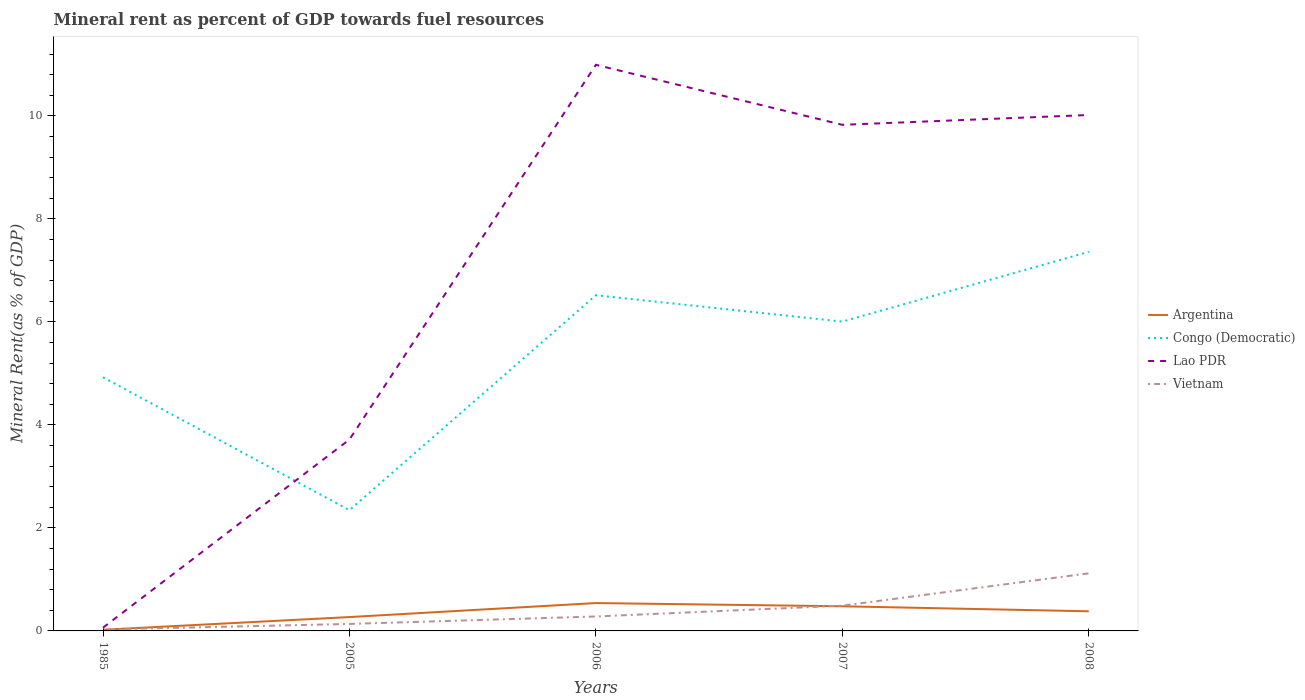Does the line corresponding to Lao PDR intersect with the line corresponding to Congo (Democratic)?
Ensure brevity in your answer.  Yes. Across all years, what is the maximum mineral rent in Congo (Democratic)?
Your answer should be compact. 2.34. In which year was the mineral rent in Congo (Democratic) maximum?
Make the answer very short. 2005. What is the total mineral rent in Vietnam in the graph?
Give a very brief answer. -0.15. What is the difference between the highest and the second highest mineral rent in Vietnam?
Offer a terse response. 1.09. How many lines are there?
Offer a very short reply. 4. What is the difference between two consecutive major ticks on the Y-axis?
Offer a terse response. 2. Are the values on the major ticks of Y-axis written in scientific E-notation?
Your response must be concise. No. Does the graph contain any zero values?
Offer a terse response. No. Where does the legend appear in the graph?
Make the answer very short. Center right. What is the title of the graph?
Give a very brief answer. Mineral rent as percent of GDP towards fuel resources. Does "Morocco" appear as one of the legend labels in the graph?
Your answer should be compact. No. What is the label or title of the X-axis?
Make the answer very short. Years. What is the label or title of the Y-axis?
Your answer should be compact. Mineral Rent(as % of GDP). What is the Mineral Rent(as % of GDP) of Argentina in 1985?
Keep it short and to the point. 0.02. What is the Mineral Rent(as % of GDP) of Congo (Democratic) in 1985?
Provide a succinct answer. 4.92. What is the Mineral Rent(as % of GDP) of Lao PDR in 1985?
Your answer should be very brief. 0.06. What is the Mineral Rent(as % of GDP) of Vietnam in 1985?
Your answer should be compact. 0.03. What is the Mineral Rent(as % of GDP) in Argentina in 2005?
Offer a terse response. 0.27. What is the Mineral Rent(as % of GDP) in Congo (Democratic) in 2005?
Provide a short and direct response. 2.34. What is the Mineral Rent(as % of GDP) of Lao PDR in 2005?
Your answer should be very brief. 3.72. What is the Mineral Rent(as % of GDP) of Vietnam in 2005?
Offer a very short reply. 0.14. What is the Mineral Rent(as % of GDP) in Argentina in 2006?
Your answer should be very brief. 0.54. What is the Mineral Rent(as % of GDP) of Congo (Democratic) in 2006?
Offer a terse response. 6.52. What is the Mineral Rent(as % of GDP) of Lao PDR in 2006?
Provide a short and direct response. 10.99. What is the Mineral Rent(as % of GDP) of Vietnam in 2006?
Keep it short and to the point. 0.28. What is the Mineral Rent(as % of GDP) in Argentina in 2007?
Offer a terse response. 0.48. What is the Mineral Rent(as % of GDP) of Congo (Democratic) in 2007?
Give a very brief answer. 6.01. What is the Mineral Rent(as % of GDP) of Lao PDR in 2007?
Offer a very short reply. 9.83. What is the Mineral Rent(as % of GDP) in Vietnam in 2007?
Your response must be concise. 0.49. What is the Mineral Rent(as % of GDP) of Argentina in 2008?
Keep it short and to the point. 0.38. What is the Mineral Rent(as % of GDP) in Congo (Democratic) in 2008?
Provide a short and direct response. 7.36. What is the Mineral Rent(as % of GDP) in Lao PDR in 2008?
Ensure brevity in your answer.  10.02. What is the Mineral Rent(as % of GDP) in Vietnam in 2008?
Provide a short and direct response. 1.12. Across all years, what is the maximum Mineral Rent(as % of GDP) of Argentina?
Provide a succinct answer. 0.54. Across all years, what is the maximum Mineral Rent(as % of GDP) in Congo (Democratic)?
Provide a succinct answer. 7.36. Across all years, what is the maximum Mineral Rent(as % of GDP) in Lao PDR?
Make the answer very short. 10.99. Across all years, what is the maximum Mineral Rent(as % of GDP) in Vietnam?
Your response must be concise. 1.12. Across all years, what is the minimum Mineral Rent(as % of GDP) of Argentina?
Provide a succinct answer. 0.02. Across all years, what is the minimum Mineral Rent(as % of GDP) in Congo (Democratic)?
Your answer should be compact. 2.34. Across all years, what is the minimum Mineral Rent(as % of GDP) in Lao PDR?
Ensure brevity in your answer.  0.06. Across all years, what is the minimum Mineral Rent(as % of GDP) of Vietnam?
Give a very brief answer. 0.03. What is the total Mineral Rent(as % of GDP) of Argentina in the graph?
Ensure brevity in your answer.  1.69. What is the total Mineral Rent(as % of GDP) in Congo (Democratic) in the graph?
Offer a terse response. 27.15. What is the total Mineral Rent(as % of GDP) in Lao PDR in the graph?
Provide a short and direct response. 34.61. What is the total Mineral Rent(as % of GDP) of Vietnam in the graph?
Give a very brief answer. 2.05. What is the difference between the Mineral Rent(as % of GDP) in Argentina in 1985 and that in 2005?
Provide a short and direct response. -0.25. What is the difference between the Mineral Rent(as % of GDP) in Congo (Democratic) in 1985 and that in 2005?
Offer a very short reply. 2.58. What is the difference between the Mineral Rent(as % of GDP) in Lao PDR in 1985 and that in 2005?
Your answer should be very brief. -3.65. What is the difference between the Mineral Rent(as % of GDP) of Vietnam in 1985 and that in 2005?
Your answer should be very brief. -0.11. What is the difference between the Mineral Rent(as % of GDP) in Argentina in 1985 and that in 2006?
Make the answer very short. -0.52. What is the difference between the Mineral Rent(as % of GDP) in Congo (Democratic) in 1985 and that in 2006?
Ensure brevity in your answer.  -1.59. What is the difference between the Mineral Rent(as % of GDP) in Lao PDR in 1985 and that in 2006?
Provide a short and direct response. -10.93. What is the difference between the Mineral Rent(as % of GDP) of Vietnam in 1985 and that in 2006?
Keep it short and to the point. -0.25. What is the difference between the Mineral Rent(as % of GDP) of Argentina in 1985 and that in 2007?
Keep it short and to the point. -0.46. What is the difference between the Mineral Rent(as % of GDP) in Congo (Democratic) in 1985 and that in 2007?
Offer a terse response. -1.08. What is the difference between the Mineral Rent(as % of GDP) of Lao PDR in 1985 and that in 2007?
Provide a short and direct response. -9.76. What is the difference between the Mineral Rent(as % of GDP) of Vietnam in 1985 and that in 2007?
Provide a short and direct response. -0.46. What is the difference between the Mineral Rent(as % of GDP) of Argentina in 1985 and that in 2008?
Provide a succinct answer. -0.36. What is the difference between the Mineral Rent(as % of GDP) of Congo (Democratic) in 1985 and that in 2008?
Provide a succinct answer. -2.43. What is the difference between the Mineral Rent(as % of GDP) of Lao PDR in 1985 and that in 2008?
Offer a very short reply. -9.95. What is the difference between the Mineral Rent(as % of GDP) of Vietnam in 1985 and that in 2008?
Ensure brevity in your answer.  -1.09. What is the difference between the Mineral Rent(as % of GDP) of Argentina in 2005 and that in 2006?
Offer a very short reply. -0.27. What is the difference between the Mineral Rent(as % of GDP) of Congo (Democratic) in 2005 and that in 2006?
Provide a short and direct response. -4.17. What is the difference between the Mineral Rent(as % of GDP) in Lao PDR in 2005 and that in 2006?
Ensure brevity in your answer.  -7.27. What is the difference between the Mineral Rent(as % of GDP) in Vietnam in 2005 and that in 2006?
Your answer should be compact. -0.14. What is the difference between the Mineral Rent(as % of GDP) in Argentina in 2005 and that in 2007?
Your response must be concise. -0.21. What is the difference between the Mineral Rent(as % of GDP) of Congo (Democratic) in 2005 and that in 2007?
Provide a succinct answer. -3.66. What is the difference between the Mineral Rent(as % of GDP) in Lao PDR in 2005 and that in 2007?
Ensure brevity in your answer.  -6.11. What is the difference between the Mineral Rent(as % of GDP) of Vietnam in 2005 and that in 2007?
Ensure brevity in your answer.  -0.35. What is the difference between the Mineral Rent(as % of GDP) in Argentina in 2005 and that in 2008?
Offer a terse response. -0.11. What is the difference between the Mineral Rent(as % of GDP) of Congo (Democratic) in 2005 and that in 2008?
Provide a succinct answer. -5.01. What is the difference between the Mineral Rent(as % of GDP) in Lao PDR in 2005 and that in 2008?
Keep it short and to the point. -6.3. What is the difference between the Mineral Rent(as % of GDP) in Vietnam in 2005 and that in 2008?
Offer a very short reply. -0.98. What is the difference between the Mineral Rent(as % of GDP) in Argentina in 2006 and that in 2007?
Your answer should be very brief. 0.06. What is the difference between the Mineral Rent(as % of GDP) in Congo (Democratic) in 2006 and that in 2007?
Provide a short and direct response. 0.51. What is the difference between the Mineral Rent(as % of GDP) in Lao PDR in 2006 and that in 2007?
Give a very brief answer. 1.16. What is the difference between the Mineral Rent(as % of GDP) in Vietnam in 2006 and that in 2007?
Give a very brief answer. -0.21. What is the difference between the Mineral Rent(as % of GDP) of Argentina in 2006 and that in 2008?
Ensure brevity in your answer.  0.16. What is the difference between the Mineral Rent(as % of GDP) in Congo (Democratic) in 2006 and that in 2008?
Keep it short and to the point. -0.84. What is the difference between the Mineral Rent(as % of GDP) in Lao PDR in 2006 and that in 2008?
Provide a short and direct response. 0.97. What is the difference between the Mineral Rent(as % of GDP) of Vietnam in 2006 and that in 2008?
Give a very brief answer. -0.84. What is the difference between the Mineral Rent(as % of GDP) of Argentina in 2007 and that in 2008?
Offer a very short reply. 0.1. What is the difference between the Mineral Rent(as % of GDP) of Congo (Democratic) in 2007 and that in 2008?
Provide a succinct answer. -1.35. What is the difference between the Mineral Rent(as % of GDP) of Lao PDR in 2007 and that in 2008?
Offer a terse response. -0.19. What is the difference between the Mineral Rent(as % of GDP) of Vietnam in 2007 and that in 2008?
Your answer should be very brief. -0.63. What is the difference between the Mineral Rent(as % of GDP) in Argentina in 1985 and the Mineral Rent(as % of GDP) in Congo (Democratic) in 2005?
Provide a succinct answer. -2.32. What is the difference between the Mineral Rent(as % of GDP) of Argentina in 1985 and the Mineral Rent(as % of GDP) of Lao PDR in 2005?
Provide a succinct answer. -3.69. What is the difference between the Mineral Rent(as % of GDP) of Argentina in 1985 and the Mineral Rent(as % of GDP) of Vietnam in 2005?
Offer a very short reply. -0.11. What is the difference between the Mineral Rent(as % of GDP) of Congo (Democratic) in 1985 and the Mineral Rent(as % of GDP) of Lao PDR in 2005?
Ensure brevity in your answer.  1.21. What is the difference between the Mineral Rent(as % of GDP) of Congo (Democratic) in 1985 and the Mineral Rent(as % of GDP) of Vietnam in 2005?
Give a very brief answer. 4.79. What is the difference between the Mineral Rent(as % of GDP) of Lao PDR in 1985 and the Mineral Rent(as % of GDP) of Vietnam in 2005?
Your response must be concise. -0.07. What is the difference between the Mineral Rent(as % of GDP) of Argentina in 1985 and the Mineral Rent(as % of GDP) of Congo (Democratic) in 2006?
Your answer should be very brief. -6.49. What is the difference between the Mineral Rent(as % of GDP) in Argentina in 1985 and the Mineral Rent(as % of GDP) in Lao PDR in 2006?
Your response must be concise. -10.97. What is the difference between the Mineral Rent(as % of GDP) of Argentina in 1985 and the Mineral Rent(as % of GDP) of Vietnam in 2006?
Keep it short and to the point. -0.26. What is the difference between the Mineral Rent(as % of GDP) of Congo (Democratic) in 1985 and the Mineral Rent(as % of GDP) of Lao PDR in 2006?
Offer a very short reply. -6.07. What is the difference between the Mineral Rent(as % of GDP) in Congo (Democratic) in 1985 and the Mineral Rent(as % of GDP) in Vietnam in 2006?
Your answer should be compact. 4.64. What is the difference between the Mineral Rent(as % of GDP) in Lao PDR in 1985 and the Mineral Rent(as % of GDP) in Vietnam in 2006?
Provide a succinct answer. -0.22. What is the difference between the Mineral Rent(as % of GDP) in Argentina in 1985 and the Mineral Rent(as % of GDP) in Congo (Democratic) in 2007?
Provide a succinct answer. -5.98. What is the difference between the Mineral Rent(as % of GDP) of Argentina in 1985 and the Mineral Rent(as % of GDP) of Lao PDR in 2007?
Make the answer very short. -9.8. What is the difference between the Mineral Rent(as % of GDP) in Argentina in 1985 and the Mineral Rent(as % of GDP) in Vietnam in 2007?
Give a very brief answer. -0.47. What is the difference between the Mineral Rent(as % of GDP) in Congo (Democratic) in 1985 and the Mineral Rent(as % of GDP) in Lao PDR in 2007?
Your answer should be compact. -4.9. What is the difference between the Mineral Rent(as % of GDP) in Congo (Democratic) in 1985 and the Mineral Rent(as % of GDP) in Vietnam in 2007?
Keep it short and to the point. 4.43. What is the difference between the Mineral Rent(as % of GDP) in Lao PDR in 1985 and the Mineral Rent(as % of GDP) in Vietnam in 2007?
Give a very brief answer. -0.43. What is the difference between the Mineral Rent(as % of GDP) of Argentina in 1985 and the Mineral Rent(as % of GDP) of Congo (Democratic) in 2008?
Offer a very short reply. -7.34. What is the difference between the Mineral Rent(as % of GDP) of Argentina in 1985 and the Mineral Rent(as % of GDP) of Lao PDR in 2008?
Your response must be concise. -9.99. What is the difference between the Mineral Rent(as % of GDP) in Argentina in 1985 and the Mineral Rent(as % of GDP) in Vietnam in 2008?
Provide a succinct answer. -1.1. What is the difference between the Mineral Rent(as % of GDP) of Congo (Democratic) in 1985 and the Mineral Rent(as % of GDP) of Lao PDR in 2008?
Offer a very short reply. -5.09. What is the difference between the Mineral Rent(as % of GDP) of Congo (Democratic) in 1985 and the Mineral Rent(as % of GDP) of Vietnam in 2008?
Your answer should be very brief. 3.81. What is the difference between the Mineral Rent(as % of GDP) of Lao PDR in 1985 and the Mineral Rent(as % of GDP) of Vietnam in 2008?
Keep it short and to the point. -1.05. What is the difference between the Mineral Rent(as % of GDP) of Argentina in 2005 and the Mineral Rent(as % of GDP) of Congo (Democratic) in 2006?
Your answer should be very brief. -6.25. What is the difference between the Mineral Rent(as % of GDP) in Argentina in 2005 and the Mineral Rent(as % of GDP) in Lao PDR in 2006?
Your answer should be compact. -10.72. What is the difference between the Mineral Rent(as % of GDP) in Argentina in 2005 and the Mineral Rent(as % of GDP) in Vietnam in 2006?
Offer a very short reply. -0.01. What is the difference between the Mineral Rent(as % of GDP) of Congo (Democratic) in 2005 and the Mineral Rent(as % of GDP) of Lao PDR in 2006?
Offer a very short reply. -8.65. What is the difference between the Mineral Rent(as % of GDP) in Congo (Democratic) in 2005 and the Mineral Rent(as % of GDP) in Vietnam in 2006?
Provide a short and direct response. 2.06. What is the difference between the Mineral Rent(as % of GDP) in Lao PDR in 2005 and the Mineral Rent(as % of GDP) in Vietnam in 2006?
Offer a very short reply. 3.44. What is the difference between the Mineral Rent(as % of GDP) of Argentina in 2005 and the Mineral Rent(as % of GDP) of Congo (Democratic) in 2007?
Your answer should be compact. -5.74. What is the difference between the Mineral Rent(as % of GDP) of Argentina in 2005 and the Mineral Rent(as % of GDP) of Lao PDR in 2007?
Give a very brief answer. -9.56. What is the difference between the Mineral Rent(as % of GDP) in Argentina in 2005 and the Mineral Rent(as % of GDP) in Vietnam in 2007?
Keep it short and to the point. -0.22. What is the difference between the Mineral Rent(as % of GDP) of Congo (Democratic) in 2005 and the Mineral Rent(as % of GDP) of Lao PDR in 2007?
Keep it short and to the point. -7.48. What is the difference between the Mineral Rent(as % of GDP) in Congo (Democratic) in 2005 and the Mineral Rent(as % of GDP) in Vietnam in 2007?
Provide a succinct answer. 1.85. What is the difference between the Mineral Rent(as % of GDP) of Lao PDR in 2005 and the Mineral Rent(as % of GDP) of Vietnam in 2007?
Offer a very short reply. 3.23. What is the difference between the Mineral Rent(as % of GDP) of Argentina in 2005 and the Mineral Rent(as % of GDP) of Congo (Democratic) in 2008?
Keep it short and to the point. -7.09. What is the difference between the Mineral Rent(as % of GDP) in Argentina in 2005 and the Mineral Rent(as % of GDP) in Lao PDR in 2008?
Your answer should be compact. -9.75. What is the difference between the Mineral Rent(as % of GDP) of Argentina in 2005 and the Mineral Rent(as % of GDP) of Vietnam in 2008?
Keep it short and to the point. -0.85. What is the difference between the Mineral Rent(as % of GDP) in Congo (Democratic) in 2005 and the Mineral Rent(as % of GDP) in Lao PDR in 2008?
Make the answer very short. -7.67. What is the difference between the Mineral Rent(as % of GDP) of Congo (Democratic) in 2005 and the Mineral Rent(as % of GDP) of Vietnam in 2008?
Ensure brevity in your answer.  1.23. What is the difference between the Mineral Rent(as % of GDP) of Lao PDR in 2005 and the Mineral Rent(as % of GDP) of Vietnam in 2008?
Your answer should be very brief. 2.6. What is the difference between the Mineral Rent(as % of GDP) in Argentina in 2006 and the Mineral Rent(as % of GDP) in Congo (Democratic) in 2007?
Make the answer very short. -5.46. What is the difference between the Mineral Rent(as % of GDP) in Argentina in 2006 and the Mineral Rent(as % of GDP) in Lao PDR in 2007?
Give a very brief answer. -9.29. What is the difference between the Mineral Rent(as % of GDP) of Argentina in 2006 and the Mineral Rent(as % of GDP) of Vietnam in 2007?
Offer a terse response. 0.05. What is the difference between the Mineral Rent(as % of GDP) in Congo (Democratic) in 2006 and the Mineral Rent(as % of GDP) in Lao PDR in 2007?
Your answer should be very brief. -3.31. What is the difference between the Mineral Rent(as % of GDP) in Congo (Democratic) in 2006 and the Mineral Rent(as % of GDP) in Vietnam in 2007?
Offer a very short reply. 6.03. What is the difference between the Mineral Rent(as % of GDP) of Lao PDR in 2006 and the Mineral Rent(as % of GDP) of Vietnam in 2007?
Provide a short and direct response. 10.5. What is the difference between the Mineral Rent(as % of GDP) in Argentina in 2006 and the Mineral Rent(as % of GDP) in Congo (Democratic) in 2008?
Ensure brevity in your answer.  -6.82. What is the difference between the Mineral Rent(as % of GDP) of Argentina in 2006 and the Mineral Rent(as % of GDP) of Lao PDR in 2008?
Offer a very short reply. -9.48. What is the difference between the Mineral Rent(as % of GDP) in Argentina in 2006 and the Mineral Rent(as % of GDP) in Vietnam in 2008?
Ensure brevity in your answer.  -0.58. What is the difference between the Mineral Rent(as % of GDP) of Congo (Democratic) in 2006 and the Mineral Rent(as % of GDP) of Lao PDR in 2008?
Provide a short and direct response. -3.5. What is the difference between the Mineral Rent(as % of GDP) of Congo (Democratic) in 2006 and the Mineral Rent(as % of GDP) of Vietnam in 2008?
Offer a very short reply. 5.4. What is the difference between the Mineral Rent(as % of GDP) in Lao PDR in 2006 and the Mineral Rent(as % of GDP) in Vietnam in 2008?
Ensure brevity in your answer.  9.87. What is the difference between the Mineral Rent(as % of GDP) of Argentina in 2007 and the Mineral Rent(as % of GDP) of Congo (Democratic) in 2008?
Keep it short and to the point. -6.88. What is the difference between the Mineral Rent(as % of GDP) of Argentina in 2007 and the Mineral Rent(as % of GDP) of Lao PDR in 2008?
Offer a very short reply. -9.54. What is the difference between the Mineral Rent(as % of GDP) of Argentina in 2007 and the Mineral Rent(as % of GDP) of Vietnam in 2008?
Offer a very short reply. -0.64. What is the difference between the Mineral Rent(as % of GDP) in Congo (Democratic) in 2007 and the Mineral Rent(as % of GDP) in Lao PDR in 2008?
Provide a succinct answer. -4.01. What is the difference between the Mineral Rent(as % of GDP) in Congo (Democratic) in 2007 and the Mineral Rent(as % of GDP) in Vietnam in 2008?
Give a very brief answer. 4.89. What is the difference between the Mineral Rent(as % of GDP) of Lao PDR in 2007 and the Mineral Rent(as % of GDP) of Vietnam in 2008?
Make the answer very short. 8.71. What is the average Mineral Rent(as % of GDP) of Argentina per year?
Provide a succinct answer. 0.34. What is the average Mineral Rent(as % of GDP) of Congo (Democratic) per year?
Your answer should be very brief. 5.43. What is the average Mineral Rent(as % of GDP) in Lao PDR per year?
Offer a very short reply. 6.92. What is the average Mineral Rent(as % of GDP) in Vietnam per year?
Your answer should be compact. 0.41. In the year 1985, what is the difference between the Mineral Rent(as % of GDP) in Argentina and Mineral Rent(as % of GDP) in Congo (Democratic)?
Provide a succinct answer. -4.9. In the year 1985, what is the difference between the Mineral Rent(as % of GDP) in Argentina and Mineral Rent(as % of GDP) in Lao PDR?
Your response must be concise. -0.04. In the year 1985, what is the difference between the Mineral Rent(as % of GDP) in Argentina and Mineral Rent(as % of GDP) in Vietnam?
Keep it short and to the point. -0.01. In the year 1985, what is the difference between the Mineral Rent(as % of GDP) in Congo (Democratic) and Mineral Rent(as % of GDP) in Lao PDR?
Your response must be concise. 4.86. In the year 1985, what is the difference between the Mineral Rent(as % of GDP) of Congo (Democratic) and Mineral Rent(as % of GDP) of Vietnam?
Your response must be concise. 4.9. In the year 1985, what is the difference between the Mineral Rent(as % of GDP) in Lao PDR and Mineral Rent(as % of GDP) in Vietnam?
Provide a succinct answer. 0.04. In the year 2005, what is the difference between the Mineral Rent(as % of GDP) in Argentina and Mineral Rent(as % of GDP) in Congo (Democratic)?
Offer a very short reply. -2.08. In the year 2005, what is the difference between the Mineral Rent(as % of GDP) in Argentina and Mineral Rent(as % of GDP) in Lao PDR?
Provide a succinct answer. -3.45. In the year 2005, what is the difference between the Mineral Rent(as % of GDP) of Argentina and Mineral Rent(as % of GDP) of Vietnam?
Make the answer very short. 0.13. In the year 2005, what is the difference between the Mineral Rent(as % of GDP) in Congo (Democratic) and Mineral Rent(as % of GDP) in Lao PDR?
Keep it short and to the point. -1.37. In the year 2005, what is the difference between the Mineral Rent(as % of GDP) of Congo (Democratic) and Mineral Rent(as % of GDP) of Vietnam?
Provide a short and direct response. 2.21. In the year 2005, what is the difference between the Mineral Rent(as % of GDP) in Lao PDR and Mineral Rent(as % of GDP) in Vietnam?
Your answer should be very brief. 3.58. In the year 2006, what is the difference between the Mineral Rent(as % of GDP) in Argentina and Mineral Rent(as % of GDP) in Congo (Democratic)?
Offer a terse response. -5.98. In the year 2006, what is the difference between the Mineral Rent(as % of GDP) of Argentina and Mineral Rent(as % of GDP) of Lao PDR?
Offer a terse response. -10.45. In the year 2006, what is the difference between the Mineral Rent(as % of GDP) in Argentina and Mineral Rent(as % of GDP) in Vietnam?
Your response must be concise. 0.26. In the year 2006, what is the difference between the Mineral Rent(as % of GDP) in Congo (Democratic) and Mineral Rent(as % of GDP) in Lao PDR?
Offer a very short reply. -4.47. In the year 2006, what is the difference between the Mineral Rent(as % of GDP) of Congo (Democratic) and Mineral Rent(as % of GDP) of Vietnam?
Your response must be concise. 6.24. In the year 2006, what is the difference between the Mineral Rent(as % of GDP) in Lao PDR and Mineral Rent(as % of GDP) in Vietnam?
Provide a short and direct response. 10.71. In the year 2007, what is the difference between the Mineral Rent(as % of GDP) of Argentina and Mineral Rent(as % of GDP) of Congo (Democratic)?
Give a very brief answer. -5.53. In the year 2007, what is the difference between the Mineral Rent(as % of GDP) of Argentina and Mineral Rent(as % of GDP) of Lao PDR?
Ensure brevity in your answer.  -9.35. In the year 2007, what is the difference between the Mineral Rent(as % of GDP) in Argentina and Mineral Rent(as % of GDP) in Vietnam?
Give a very brief answer. -0.01. In the year 2007, what is the difference between the Mineral Rent(as % of GDP) of Congo (Democratic) and Mineral Rent(as % of GDP) of Lao PDR?
Provide a succinct answer. -3.82. In the year 2007, what is the difference between the Mineral Rent(as % of GDP) in Congo (Democratic) and Mineral Rent(as % of GDP) in Vietnam?
Offer a very short reply. 5.52. In the year 2007, what is the difference between the Mineral Rent(as % of GDP) in Lao PDR and Mineral Rent(as % of GDP) in Vietnam?
Offer a very short reply. 9.34. In the year 2008, what is the difference between the Mineral Rent(as % of GDP) of Argentina and Mineral Rent(as % of GDP) of Congo (Democratic)?
Your response must be concise. -6.98. In the year 2008, what is the difference between the Mineral Rent(as % of GDP) in Argentina and Mineral Rent(as % of GDP) in Lao PDR?
Provide a short and direct response. -9.64. In the year 2008, what is the difference between the Mineral Rent(as % of GDP) in Argentina and Mineral Rent(as % of GDP) in Vietnam?
Give a very brief answer. -0.74. In the year 2008, what is the difference between the Mineral Rent(as % of GDP) in Congo (Democratic) and Mineral Rent(as % of GDP) in Lao PDR?
Your response must be concise. -2.66. In the year 2008, what is the difference between the Mineral Rent(as % of GDP) of Congo (Democratic) and Mineral Rent(as % of GDP) of Vietnam?
Offer a terse response. 6.24. In the year 2008, what is the difference between the Mineral Rent(as % of GDP) in Lao PDR and Mineral Rent(as % of GDP) in Vietnam?
Your answer should be compact. 8.9. What is the ratio of the Mineral Rent(as % of GDP) in Argentina in 1985 to that in 2005?
Your answer should be very brief. 0.08. What is the ratio of the Mineral Rent(as % of GDP) of Congo (Democratic) in 1985 to that in 2005?
Offer a very short reply. 2.1. What is the ratio of the Mineral Rent(as % of GDP) of Lao PDR in 1985 to that in 2005?
Keep it short and to the point. 0.02. What is the ratio of the Mineral Rent(as % of GDP) in Vietnam in 1985 to that in 2005?
Offer a terse response. 0.21. What is the ratio of the Mineral Rent(as % of GDP) of Argentina in 1985 to that in 2006?
Offer a very short reply. 0.04. What is the ratio of the Mineral Rent(as % of GDP) in Congo (Democratic) in 1985 to that in 2006?
Ensure brevity in your answer.  0.76. What is the ratio of the Mineral Rent(as % of GDP) in Lao PDR in 1985 to that in 2006?
Provide a short and direct response. 0.01. What is the ratio of the Mineral Rent(as % of GDP) in Vietnam in 1985 to that in 2006?
Ensure brevity in your answer.  0.1. What is the ratio of the Mineral Rent(as % of GDP) of Argentina in 1985 to that in 2007?
Give a very brief answer. 0.05. What is the ratio of the Mineral Rent(as % of GDP) in Congo (Democratic) in 1985 to that in 2007?
Offer a very short reply. 0.82. What is the ratio of the Mineral Rent(as % of GDP) of Lao PDR in 1985 to that in 2007?
Provide a succinct answer. 0.01. What is the ratio of the Mineral Rent(as % of GDP) in Vietnam in 1985 to that in 2007?
Give a very brief answer. 0.06. What is the ratio of the Mineral Rent(as % of GDP) of Argentina in 1985 to that in 2008?
Provide a succinct answer. 0.06. What is the ratio of the Mineral Rent(as % of GDP) of Congo (Democratic) in 1985 to that in 2008?
Provide a succinct answer. 0.67. What is the ratio of the Mineral Rent(as % of GDP) in Lao PDR in 1985 to that in 2008?
Your answer should be compact. 0.01. What is the ratio of the Mineral Rent(as % of GDP) in Vietnam in 1985 to that in 2008?
Offer a very short reply. 0.03. What is the ratio of the Mineral Rent(as % of GDP) of Argentina in 2005 to that in 2006?
Ensure brevity in your answer.  0.5. What is the ratio of the Mineral Rent(as % of GDP) in Congo (Democratic) in 2005 to that in 2006?
Give a very brief answer. 0.36. What is the ratio of the Mineral Rent(as % of GDP) in Lao PDR in 2005 to that in 2006?
Provide a short and direct response. 0.34. What is the ratio of the Mineral Rent(as % of GDP) of Vietnam in 2005 to that in 2006?
Provide a short and direct response. 0.48. What is the ratio of the Mineral Rent(as % of GDP) in Argentina in 2005 to that in 2007?
Your response must be concise. 0.56. What is the ratio of the Mineral Rent(as % of GDP) of Congo (Democratic) in 2005 to that in 2007?
Give a very brief answer. 0.39. What is the ratio of the Mineral Rent(as % of GDP) in Lao PDR in 2005 to that in 2007?
Keep it short and to the point. 0.38. What is the ratio of the Mineral Rent(as % of GDP) of Vietnam in 2005 to that in 2007?
Make the answer very short. 0.28. What is the ratio of the Mineral Rent(as % of GDP) of Argentina in 2005 to that in 2008?
Your answer should be compact. 0.71. What is the ratio of the Mineral Rent(as % of GDP) of Congo (Democratic) in 2005 to that in 2008?
Your answer should be compact. 0.32. What is the ratio of the Mineral Rent(as % of GDP) in Lao PDR in 2005 to that in 2008?
Provide a short and direct response. 0.37. What is the ratio of the Mineral Rent(as % of GDP) in Vietnam in 2005 to that in 2008?
Keep it short and to the point. 0.12. What is the ratio of the Mineral Rent(as % of GDP) in Argentina in 2006 to that in 2007?
Make the answer very short. 1.13. What is the ratio of the Mineral Rent(as % of GDP) in Congo (Democratic) in 2006 to that in 2007?
Make the answer very short. 1.09. What is the ratio of the Mineral Rent(as % of GDP) of Lao PDR in 2006 to that in 2007?
Offer a very short reply. 1.12. What is the ratio of the Mineral Rent(as % of GDP) in Vietnam in 2006 to that in 2007?
Your response must be concise. 0.57. What is the ratio of the Mineral Rent(as % of GDP) of Argentina in 2006 to that in 2008?
Offer a terse response. 1.42. What is the ratio of the Mineral Rent(as % of GDP) of Congo (Democratic) in 2006 to that in 2008?
Your answer should be very brief. 0.89. What is the ratio of the Mineral Rent(as % of GDP) in Lao PDR in 2006 to that in 2008?
Provide a short and direct response. 1.1. What is the ratio of the Mineral Rent(as % of GDP) in Vietnam in 2006 to that in 2008?
Offer a terse response. 0.25. What is the ratio of the Mineral Rent(as % of GDP) of Argentina in 2007 to that in 2008?
Offer a very short reply. 1.26. What is the ratio of the Mineral Rent(as % of GDP) in Congo (Democratic) in 2007 to that in 2008?
Your answer should be compact. 0.82. What is the ratio of the Mineral Rent(as % of GDP) in Vietnam in 2007 to that in 2008?
Your answer should be very brief. 0.44. What is the difference between the highest and the second highest Mineral Rent(as % of GDP) in Argentina?
Provide a succinct answer. 0.06. What is the difference between the highest and the second highest Mineral Rent(as % of GDP) of Congo (Democratic)?
Give a very brief answer. 0.84. What is the difference between the highest and the second highest Mineral Rent(as % of GDP) of Lao PDR?
Give a very brief answer. 0.97. What is the difference between the highest and the second highest Mineral Rent(as % of GDP) in Vietnam?
Keep it short and to the point. 0.63. What is the difference between the highest and the lowest Mineral Rent(as % of GDP) in Argentina?
Offer a very short reply. 0.52. What is the difference between the highest and the lowest Mineral Rent(as % of GDP) of Congo (Democratic)?
Your answer should be very brief. 5.01. What is the difference between the highest and the lowest Mineral Rent(as % of GDP) in Lao PDR?
Make the answer very short. 10.93. What is the difference between the highest and the lowest Mineral Rent(as % of GDP) of Vietnam?
Your response must be concise. 1.09. 